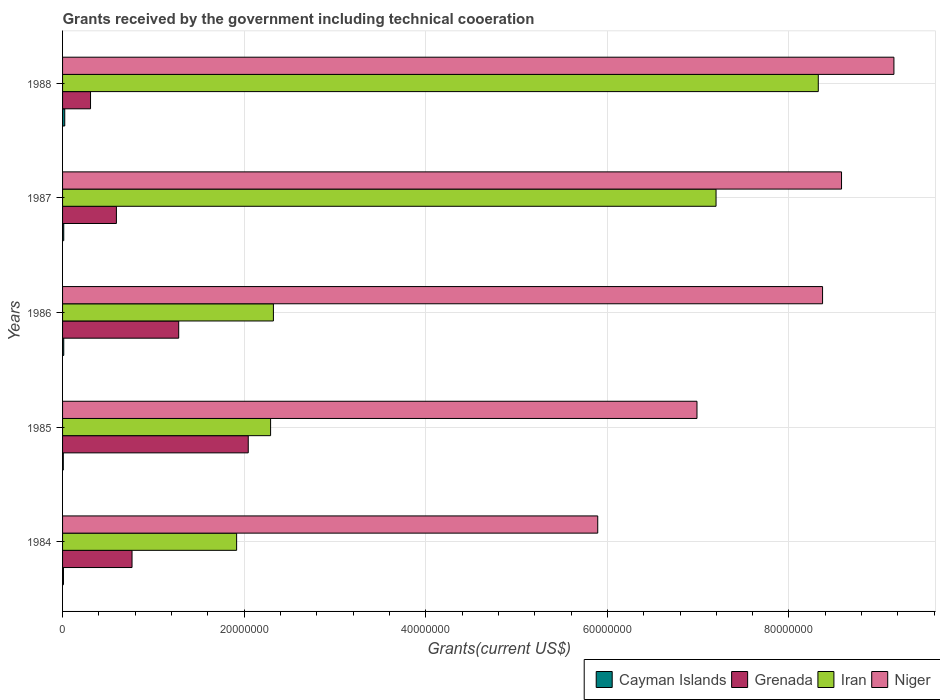How many different coloured bars are there?
Provide a succinct answer. 4. Are the number of bars per tick equal to the number of legend labels?
Your answer should be very brief. Yes. How many bars are there on the 4th tick from the bottom?
Your response must be concise. 4. What is the label of the 1st group of bars from the top?
Provide a short and direct response. 1988. In how many cases, is the number of bars for a given year not equal to the number of legend labels?
Your answer should be very brief. 0. What is the total grants received by the government in Iran in 1986?
Your response must be concise. 2.32e+07. Across all years, what is the minimum total grants received by the government in Grenada?
Keep it short and to the point. 3.08e+06. In which year was the total grants received by the government in Grenada maximum?
Ensure brevity in your answer.  1985. What is the total total grants received by the government in Cayman Islands in the graph?
Keep it short and to the point. 6.80e+05. What is the difference between the total grants received by the government in Iran in 1985 and that in 1986?
Offer a very short reply. -3.10e+05. What is the difference between the total grants received by the government in Iran in 1988 and the total grants received by the government in Cayman Islands in 1985?
Offer a terse response. 8.32e+07. What is the average total grants received by the government in Iran per year?
Your answer should be very brief. 4.41e+07. In the year 1988, what is the difference between the total grants received by the government in Niger and total grants received by the government in Cayman Islands?
Offer a terse response. 9.13e+07. What is the ratio of the total grants received by the government in Niger in 1985 to that in 1987?
Make the answer very short. 0.81. What is the difference between the highest and the second highest total grants received by the government in Grenada?
Ensure brevity in your answer.  7.66e+06. What is the difference between the highest and the lowest total grants received by the government in Iran?
Your response must be concise. 6.41e+07. In how many years, is the total grants received by the government in Cayman Islands greater than the average total grants received by the government in Cayman Islands taken over all years?
Your answer should be compact. 1. What does the 2nd bar from the top in 1988 represents?
Offer a very short reply. Iran. What does the 4th bar from the bottom in 1987 represents?
Give a very brief answer. Niger. Is it the case that in every year, the sum of the total grants received by the government in Niger and total grants received by the government in Cayman Islands is greater than the total grants received by the government in Grenada?
Your answer should be very brief. Yes. How many bars are there?
Ensure brevity in your answer.  20. Are all the bars in the graph horizontal?
Provide a succinct answer. Yes. What is the difference between two consecutive major ticks on the X-axis?
Your answer should be very brief. 2.00e+07. Does the graph contain any zero values?
Provide a succinct answer. No. Where does the legend appear in the graph?
Provide a short and direct response. Bottom right. How many legend labels are there?
Your answer should be very brief. 4. What is the title of the graph?
Keep it short and to the point. Grants received by the government including technical cooeration. Does "Hong Kong" appear as one of the legend labels in the graph?
Offer a terse response. No. What is the label or title of the X-axis?
Your answer should be compact. Grants(current US$). What is the Grants(current US$) in Grenada in 1984?
Your response must be concise. 7.65e+06. What is the Grants(current US$) in Iran in 1984?
Provide a succinct answer. 1.92e+07. What is the Grants(current US$) of Niger in 1984?
Give a very brief answer. 5.89e+07. What is the Grants(current US$) in Grenada in 1985?
Offer a very short reply. 2.04e+07. What is the Grants(current US$) of Iran in 1985?
Your response must be concise. 2.29e+07. What is the Grants(current US$) of Niger in 1985?
Ensure brevity in your answer.  6.99e+07. What is the Grants(current US$) of Grenada in 1986?
Provide a succinct answer. 1.28e+07. What is the Grants(current US$) of Iran in 1986?
Give a very brief answer. 2.32e+07. What is the Grants(current US$) of Niger in 1986?
Your response must be concise. 8.37e+07. What is the Grants(current US$) in Cayman Islands in 1987?
Make the answer very short. 1.30e+05. What is the Grants(current US$) in Grenada in 1987?
Your answer should be compact. 5.93e+06. What is the Grants(current US$) in Iran in 1987?
Provide a succinct answer. 7.20e+07. What is the Grants(current US$) in Niger in 1987?
Your answer should be compact. 8.58e+07. What is the Grants(current US$) in Grenada in 1988?
Your response must be concise. 3.08e+06. What is the Grants(current US$) of Iran in 1988?
Provide a succinct answer. 8.32e+07. What is the Grants(current US$) of Niger in 1988?
Give a very brief answer. 9.16e+07. Across all years, what is the maximum Grants(current US$) in Grenada?
Provide a short and direct response. 2.04e+07. Across all years, what is the maximum Grants(current US$) of Iran?
Your answer should be very brief. 8.32e+07. Across all years, what is the maximum Grants(current US$) in Niger?
Make the answer very short. 9.16e+07. Across all years, what is the minimum Grants(current US$) of Grenada?
Your response must be concise. 3.08e+06. Across all years, what is the minimum Grants(current US$) in Iran?
Offer a terse response. 1.92e+07. Across all years, what is the minimum Grants(current US$) in Niger?
Offer a very short reply. 5.89e+07. What is the total Grants(current US$) in Cayman Islands in the graph?
Give a very brief answer. 6.80e+05. What is the total Grants(current US$) in Grenada in the graph?
Make the answer very short. 4.99e+07. What is the total Grants(current US$) of Iran in the graph?
Keep it short and to the point. 2.20e+08. What is the total Grants(current US$) of Niger in the graph?
Make the answer very short. 3.90e+08. What is the difference between the Grants(current US$) of Grenada in 1984 and that in 1985?
Provide a succinct answer. -1.28e+07. What is the difference between the Grants(current US$) in Iran in 1984 and that in 1985?
Make the answer very short. -3.74e+06. What is the difference between the Grants(current US$) in Niger in 1984 and that in 1985?
Your response must be concise. -1.09e+07. What is the difference between the Grants(current US$) of Cayman Islands in 1984 and that in 1986?
Your answer should be very brief. -3.00e+04. What is the difference between the Grants(current US$) of Grenada in 1984 and that in 1986?
Your response must be concise. -5.14e+06. What is the difference between the Grants(current US$) in Iran in 1984 and that in 1986?
Your response must be concise. -4.05e+06. What is the difference between the Grants(current US$) of Niger in 1984 and that in 1986?
Ensure brevity in your answer.  -2.48e+07. What is the difference between the Grants(current US$) in Grenada in 1984 and that in 1987?
Ensure brevity in your answer.  1.72e+06. What is the difference between the Grants(current US$) in Iran in 1984 and that in 1987?
Your answer should be very brief. -5.28e+07. What is the difference between the Grants(current US$) in Niger in 1984 and that in 1987?
Offer a very short reply. -2.68e+07. What is the difference between the Grants(current US$) of Grenada in 1984 and that in 1988?
Offer a very short reply. 4.57e+06. What is the difference between the Grants(current US$) of Iran in 1984 and that in 1988?
Offer a very short reply. -6.41e+07. What is the difference between the Grants(current US$) in Niger in 1984 and that in 1988?
Make the answer very short. -3.26e+07. What is the difference between the Grants(current US$) in Grenada in 1985 and that in 1986?
Your answer should be very brief. 7.66e+06. What is the difference between the Grants(current US$) of Iran in 1985 and that in 1986?
Keep it short and to the point. -3.10e+05. What is the difference between the Grants(current US$) of Niger in 1985 and that in 1986?
Keep it short and to the point. -1.38e+07. What is the difference between the Grants(current US$) in Grenada in 1985 and that in 1987?
Your answer should be very brief. 1.45e+07. What is the difference between the Grants(current US$) in Iran in 1985 and that in 1987?
Provide a short and direct response. -4.91e+07. What is the difference between the Grants(current US$) of Niger in 1985 and that in 1987?
Your answer should be compact. -1.59e+07. What is the difference between the Grants(current US$) of Cayman Islands in 1985 and that in 1988?
Ensure brevity in your answer.  -1.60e+05. What is the difference between the Grants(current US$) of Grenada in 1985 and that in 1988?
Offer a terse response. 1.74e+07. What is the difference between the Grants(current US$) of Iran in 1985 and that in 1988?
Give a very brief answer. -6.03e+07. What is the difference between the Grants(current US$) in Niger in 1985 and that in 1988?
Offer a terse response. -2.17e+07. What is the difference between the Grants(current US$) in Cayman Islands in 1986 and that in 1987?
Give a very brief answer. 0. What is the difference between the Grants(current US$) of Grenada in 1986 and that in 1987?
Provide a succinct answer. 6.86e+06. What is the difference between the Grants(current US$) in Iran in 1986 and that in 1987?
Ensure brevity in your answer.  -4.88e+07. What is the difference between the Grants(current US$) of Niger in 1986 and that in 1987?
Provide a short and direct response. -2.09e+06. What is the difference between the Grants(current US$) of Cayman Islands in 1986 and that in 1988?
Give a very brief answer. -1.10e+05. What is the difference between the Grants(current US$) of Grenada in 1986 and that in 1988?
Make the answer very short. 9.71e+06. What is the difference between the Grants(current US$) of Iran in 1986 and that in 1988?
Offer a very short reply. -6.00e+07. What is the difference between the Grants(current US$) in Niger in 1986 and that in 1988?
Provide a succinct answer. -7.86e+06. What is the difference between the Grants(current US$) in Cayman Islands in 1987 and that in 1988?
Give a very brief answer. -1.10e+05. What is the difference between the Grants(current US$) of Grenada in 1987 and that in 1988?
Offer a very short reply. 2.85e+06. What is the difference between the Grants(current US$) of Iran in 1987 and that in 1988?
Your answer should be compact. -1.13e+07. What is the difference between the Grants(current US$) of Niger in 1987 and that in 1988?
Your answer should be very brief. -5.77e+06. What is the difference between the Grants(current US$) in Cayman Islands in 1984 and the Grants(current US$) in Grenada in 1985?
Your answer should be very brief. -2.04e+07. What is the difference between the Grants(current US$) in Cayman Islands in 1984 and the Grants(current US$) in Iran in 1985?
Offer a very short reply. -2.28e+07. What is the difference between the Grants(current US$) of Cayman Islands in 1984 and the Grants(current US$) of Niger in 1985?
Your response must be concise. -6.98e+07. What is the difference between the Grants(current US$) in Grenada in 1984 and the Grants(current US$) in Iran in 1985?
Offer a very short reply. -1.53e+07. What is the difference between the Grants(current US$) of Grenada in 1984 and the Grants(current US$) of Niger in 1985?
Give a very brief answer. -6.22e+07. What is the difference between the Grants(current US$) of Iran in 1984 and the Grants(current US$) of Niger in 1985?
Ensure brevity in your answer.  -5.07e+07. What is the difference between the Grants(current US$) of Cayman Islands in 1984 and the Grants(current US$) of Grenada in 1986?
Your response must be concise. -1.27e+07. What is the difference between the Grants(current US$) in Cayman Islands in 1984 and the Grants(current US$) in Iran in 1986?
Provide a short and direct response. -2.31e+07. What is the difference between the Grants(current US$) of Cayman Islands in 1984 and the Grants(current US$) of Niger in 1986?
Offer a very short reply. -8.36e+07. What is the difference between the Grants(current US$) of Grenada in 1984 and the Grants(current US$) of Iran in 1986?
Offer a terse response. -1.56e+07. What is the difference between the Grants(current US$) in Grenada in 1984 and the Grants(current US$) in Niger in 1986?
Ensure brevity in your answer.  -7.60e+07. What is the difference between the Grants(current US$) in Iran in 1984 and the Grants(current US$) in Niger in 1986?
Your answer should be compact. -6.45e+07. What is the difference between the Grants(current US$) of Cayman Islands in 1984 and the Grants(current US$) of Grenada in 1987?
Give a very brief answer. -5.83e+06. What is the difference between the Grants(current US$) of Cayman Islands in 1984 and the Grants(current US$) of Iran in 1987?
Ensure brevity in your answer.  -7.19e+07. What is the difference between the Grants(current US$) of Cayman Islands in 1984 and the Grants(current US$) of Niger in 1987?
Your answer should be compact. -8.57e+07. What is the difference between the Grants(current US$) of Grenada in 1984 and the Grants(current US$) of Iran in 1987?
Provide a short and direct response. -6.43e+07. What is the difference between the Grants(current US$) of Grenada in 1984 and the Grants(current US$) of Niger in 1987?
Your answer should be very brief. -7.81e+07. What is the difference between the Grants(current US$) of Iran in 1984 and the Grants(current US$) of Niger in 1987?
Provide a short and direct response. -6.66e+07. What is the difference between the Grants(current US$) in Cayman Islands in 1984 and the Grants(current US$) in Grenada in 1988?
Make the answer very short. -2.98e+06. What is the difference between the Grants(current US$) of Cayman Islands in 1984 and the Grants(current US$) of Iran in 1988?
Offer a terse response. -8.31e+07. What is the difference between the Grants(current US$) in Cayman Islands in 1984 and the Grants(current US$) in Niger in 1988?
Offer a very short reply. -9.15e+07. What is the difference between the Grants(current US$) in Grenada in 1984 and the Grants(current US$) in Iran in 1988?
Your answer should be very brief. -7.56e+07. What is the difference between the Grants(current US$) of Grenada in 1984 and the Grants(current US$) of Niger in 1988?
Make the answer very short. -8.39e+07. What is the difference between the Grants(current US$) in Iran in 1984 and the Grants(current US$) in Niger in 1988?
Your answer should be compact. -7.24e+07. What is the difference between the Grants(current US$) in Cayman Islands in 1985 and the Grants(current US$) in Grenada in 1986?
Give a very brief answer. -1.27e+07. What is the difference between the Grants(current US$) in Cayman Islands in 1985 and the Grants(current US$) in Iran in 1986?
Your answer should be very brief. -2.31e+07. What is the difference between the Grants(current US$) of Cayman Islands in 1985 and the Grants(current US$) of Niger in 1986?
Provide a succinct answer. -8.36e+07. What is the difference between the Grants(current US$) in Grenada in 1985 and the Grants(current US$) in Iran in 1986?
Your answer should be compact. -2.77e+06. What is the difference between the Grants(current US$) in Grenada in 1985 and the Grants(current US$) in Niger in 1986?
Give a very brief answer. -6.32e+07. What is the difference between the Grants(current US$) in Iran in 1985 and the Grants(current US$) in Niger in 1986?
Ensure brevity in your answer.  -6.08e+07. What is the difference between the Grants(current US$) in Cayman Islands in 1985 and the Grants(current US$) in Grenada in 1987?
Your response must be concise. -5.85e+06. What is the difference between the Grants(current US$) of Cayman Islands in 1985 and the Grants(current US$) of Iran in 1987?
Give a very brief answer. -7.19e+07. What is the difference between the Grants(current US$) of Cayman Islands in 1985 and the Grants(current US$) of Niger in 1987?
Provide a short and direct response. -8.57e+07. What is the difference between the Grants(current US$) of Grenada in 1985 and the Grants(current US$) of Iran in 1987?
Your response must be concise. -5.15e+07. What is the difference between the Grants(current US$) of Grenada in 1985 and the Grants(current US$) of Niger in 1987?
Your answer should be compact. -6.53e+07. What is the difference between the Grants(current US$) in Iran in 1985 and the Grants(current US$) in Niger in 1987?
Provide a succinct answer. -6.29e+07. What is the difference between the Grants(current US$) in Cayman Islands in 1985 and the Grants(current US$) in Iran in 1988?
Keep it short and to the point. -8.32e+07. What is the difference between the Grants(current US$) in Cayman Islands in 1985 and the Grants(current US$) in Niger in 1988?
Keep it short and to the point. -9.15e+07. What is the difference between the Grants(current US$) in Grenada in 1985 and the Grants(current US$) in Iran in 1988?
Provide a succinct answer. -6.28e+07. What is the difference between the Grants(current US$) in Grenada in 1985 and the Grants(current US$) in Niger in 1988?
Your response must be concise. -7.11e+07. What is the difference between the Grants(current US$) of Iran in 1985 and the Grants(current US$) of Niger in 1988?
Your response must be concise. -6.86e+07. What is the difference between the Grants(current US$) of Cayman Islands in 1986 and the Grants(current US$) of Grenada in 1987?
Keep it short and to the point. -5.80e+06. What is the difference between the Grants(current US$) of Cayman Islands in 1986 and the Grants(current US$) of Iran in 1987?
Keep it short and to the point. -7.18e+07. What is the difference between the Grants(current US$) in Cayman Islands in 1986 and the Grants(current US$) in Niger in 1987?
Offer a terse response. -8.57e+07. What is the difference between the Grants(current US$) of Grenada in 1986 and the Grants(current US$) of Iran in 1987?
Offer a terse response. -5.92e+07. What is the difference between the Grants(current US$) of Grenada in 1986 and the Grants(current US$) of Niger in 1987?
Keep it short and to the point. -7.30e+07. What is the difference between the Grants(current US$) in Iran in 1986 and the Grants(current US$) in Niger in 1987?
Provide a short and direct response. -6.26e+07. What is the difference between the Grants(current US$) in Cayman Islands in 1986 and the Grants(current US$) in Grenada in 1988?
Offer a terse response. -2.95e+06. What is the difference between the Grants(current US$) of Cayman Islands in 1986 and the Grants(current US$) of Iran in 1988?
Keep it short and to the point. -8.31e+07. What is the difference between the Grants(current US$) in Cayman Islands in 1986 and the Grants(current US$) in Niger in 1988?
Your response must be concise. -9.14e+07. What is the difference between the Grants(current US$) of Grenada in 1986 and the Grants(current US$) of Iran in 1988?
Your answer should be very brief. -7.04e+07. What is the difference between the Grants(current US$) in Grenada in 1986 and the Grants(current US$) in Niger in 1988?
Your answer should be very brief. -7.88e+07. What is the difference between the Grants(current US$) in Iran in 1986 and the Grants(current US$) in Niger in 1988?
Provide a short and direct response. -6.83e+07. What is the difference between the Grants(current US$) of Cayman Islands in 1987 and the Grants(current US$) of Grenada in 1988?
Provide a succinct answer. -2.95e+06. What is the difference between the Grants(current US$) of Cayman Islands in 1987 and the Grants(current US$) of Iran in 1988?
Offer a very short reply. -8.31e+07. What is the difference between the Grants(current US$) of Cayman Islands in 1987 and the Grants(current US$) of Niger in 1988?
Offer a very short reply. -9.14e+07. What is the difference between the Grants(current US$) in Grenada in 1987 and the Grants(current US$) in Iran in 1988?
Your answer should be very brief. -7.73e+07. What is the difference between the Grants(current US$) in Grenada in 1987 and the Grants(current US$) in Niger in 1988?
Keep it short and to the point. -8.56e+07. What is the difference between the Grants(current US$) in Iran in 1987 and the Grants(current US$) in Niger in 1988?
Your answer should be very brief. -1.96e+07. What is the average Grants(current US$) of Cayman Islands per year?
Provide a succinct answer. 1.36e+05. What is the average Grants(current US$) in Grenada per year?
Ensure brevity in your answer.  9.98e+06. What is the average Grants(current US$) in Iran per year?
Offer a terse response. 4.41e+07. What is the average Grants(current US$) in Niger per year?
Offer a very short reply. 7.80e+07. In the year 1984, what is the difference between the Grants(current US$) of Cayman Islands and Grants(current US$) of Grenada?
Keep it short and to the point. -7.55e+06. In the year 1984, what is the difference between the Grants(current US$) of Cayman Islands and Grants(current US$) of Iran?
Provide a short and direct response. -1.91e+07. In the year 1984, what is the difference between the Grants(current US$) in Cayman Islands and Grants(current US$) in Niger?
Ensure brevity in your answer.  -5.88e+07. In the year 1984, what is the difference between the Grants(current US$) of Grenada and Grants(current US$) of Iran?
Offer a very short reply. -1.15e+07. In the year 1984, what is the difference between the Grants(current US$) of Grenada and Grants(current US$) of Niger?
Make the answer very short. -5.13e+07. In the year 1984, what is the difference between the Grants(current US$) of Iran and Grants(current US$) of Niger?
Provide a succinct answer. -3.98e+07. In the year 1985, what is the difference between the Grants(current US$) of Cayman Islands and Grants(current US$) of Grenada?
Keep it short and to the point. -2.04e+07. In the year 1985, what is the difference between the Grants(current US$) of Cayman Islands and Grants(current US$) of Iran?
Provide a succinct answer. -2.28e+07. In the year 1985, what is the difference between the Grants(current US$) in Cayman Islands and Grants(current US$) in Niger?
Your answer should be very brief. -6.98e+07. In the year 1985, what is the difference between the Grants(current US$) of Grenada and Grants(current US$) of Iran?
Offer a very short reply. -2.46e+06. In the year 1985, what is the difference between the Grants(current US$) of Grenada and Grants(current US$) of Niger?
Provide a short and direct response. -4.94e+07. In the year 1985, what is the difference between the Grants(current US$) of Iran and Grants(current US$) of Niger?
Ensure brevity in your answer.  -4.70e+07. In the year 1986, what is the difference between the Grants(current US$) in Cayman Islands and Grants(current US$) in Grenada?
Your response must be concise. -1.27e+07. In the year 1986, what is the difference between the Grants(current US$) in Cayman Islands and Grants(current US$) in Iran?
Offer a terse response. -2.31e+07. In the year 1986, what is the difference between the Grants(current US$) of Cayman Islands and Grants(current US$) of Niger?
Ensure brevity in your answer.  -8.36e+07. In the year 1986, what is the difference between the Grants(current US$) of Grenada and Grants(current US$) of Iran?
Ensure brevity in your answer.  -1.04e+07. In the year 1986, what is the difference between the Grants(current US$) in Grenada and Grants(current US$) in Niger?
Give a very brief answer. -7.09e+07. In the year 1986, what is the difference between the Grants(current US$) in Iran and Grants(current US$) in Niger?
Make the answer very short. -6.05e+07. In the year 1987, what is the difference between the Grants(current US$) of Cayman Islands and Grants(current US$) of Grenada?
Make the answer very short. -5.80e+06. In the year 1987, what is the difference between the Grants(current US$) in Cayman Islands and Grants(current US$) in Iran?
Keep it short and to the point. -7.18e+07. In the year 1987, what is the difference between the Grants(current US$) of Cayman Islands and Grants(current US$) of Niger?
Offer a very short reply. -8.57e+07. In the year 1987, what is the difference between the Grants(current US$) in Grenada and Grants(current US$) in Iran?
Make the answer very short. -6.60e+07. In the year 1987, what is the difference between the Grants(current US$) in Grenada and Grants(current US$) in Niger?
Your answer should be very brief. -7.99e+07. In the year 1987, what is the difference between the Grants(current US$) of Iran and Grants(current US$) of Niger?
Make the answer very short. -1.38e+07. In the year 1988, what is the difference between the Grants(current US$) in Cayman Islands and Grants(current US$) in Grenada?
Your answer should be compact. -2.84e+06. In the year 1988, what is the difference between the Grants(current US$) of Cayman Islands and Grants(current US$) of Iran?
Make the answer very short. -8.30e+07. In the year 1988, what is the difference between the Grants(current US$) in Cayman Islands and Grants(current US$) in Niger?
Make the answer very short. -9.13e+07. In the year 1988, what is the difference between the Grants(current US$) of Grenada and Grants(current US$) of Iran?
Provide a short and direct response. -8.02e+07. In the year 1988, what is the difference between the Grants(current US$) of Grenada and Grants(current US$) of Niger?
Offer a terse response. -8.85e+07. In the year 1988, what is the difference between the Grants(current US$) of Iran and Grants(current US$) of Niger?
Provide a succinct answer. -8.33e+06. What is the ratio of the Grants(current US$) in Grenada in 1984 to that in 1985?
Your response must be concise. 0.37. What is the ratio of the Grants(current US$) of Iran in 1984 to that in 1985?
Offer a very short reply. 0.84. What is the ratio of the Grants(current US$) of Niger in 1984 to that in 1985?
Your response must be concise. 0.84. What is the ratio of the Grants(current US$) of Cayman Islands in 1984 to that in 1986?
Make the answer very short. 0.77. What is the ratio of the Grants(current US$) of Grenada in 1984 to that in 1986?
Provide a short and direct response. 0.6. What is the ratio of the Grants(current US$) of Iran in 1984 to that in 1986?
Offer a terse response. 0.83. What is the ratio of the Grants(current US$) of Niger in 1984 to that in 1986?
Offer a terse response. 0.7. What is the ratio of the Grants(current US$) in Cayman Islands in 1984 to that in 1987?
Make the answer very short. 0.77. What is the ratio of the Grants(current US$) in Grenada in 1984 to that in 1987?
Provide a succinct answer. 1.29. What is the ratio of the Grants(current US$) of Iran in 1984 to that in 1987?
Offer a terse response. 0.27. What is the ratio of the Grants(current US$) of Niger in 1984 to that in 1987?
Offer a terse response. 0.69. What is the ratio of the Grants(current US$) in Cayman Islands in 1984 to that in 1988?
Provide a short and direct response. 0.42. What is the ratio of the Grants(current US$) in Grenada in 1984 to that in 1988?
Offer a very short reply. 2.48. What is the ratio of the Grants(current US$) in Iran in 1984 to that in 1988?
Ensure brevity in your answer.  0.23. What is the ratio of the Grants(current US$) of Niger in 1984 to that in 1988?
Keep it short and to the point. 0.64. What is the ratio of the Grants(current US$) in Cayman Islands in 1985 to that in 1986?
Give a very brief answer. 0.62. What is the ratio of the Grants(current US$) of Grenada in 1985 to that in 1986?
Your answer should be compact. 1.6. What is the ratio of the Grants(current US$) of Iran in 1985 to that in 1986?
Provide a short and direct response. 0.99. What is the ratio of the Grants(current US$) of Niger in 1985 to that in 1986?
Your answer should be very brief. 0.83. What is the ratio of the Grants(current US$) of Cayman Islands in 1985 to that in 1987?
Give a very brief answer. 0.62. What is the ratio of the Grants(current US$) of Grenada in 1985 to that in 1987?
Offer a terse response. 3.45. What is the ratio of the Grants(current US$) of Iran in 1985 to that in 1987?
Offer a terse response. 0.32. What is the ratio of the Grants(current US$) of Niger in 1985 to that in 1987?
Your answer should be compact. 0.81. What is the ratio of the Grants(current US$) of Grenada in 1985 to that in 1988?
Ensure brevity in your answer.  6.64. What is the ratio of the Grants(current US$) of Iran in 1985 to that in 1988?
Your answer should be compact. 0.28. What is the ratio of the Grants(current US$) in Niger in 1985 to that in 1988?
Provide a succinct answer. 0.76. What is the ratio of the Grants(current US$) of Grenada in 1986 to that in 1987?
Make the answer very short. 2.16. What is the ratio of the Grants(current US$) of Iran in 1986 to that in 1987?
Provide a short and direct response. 0.32. What is the ratio of the Grants(current US$) of Niger in 1986 to that in 1987?
Your answer should be very brief. 0.98. What is the ratio of the Grants(current US$) of Cayman Islands in 1986 to that in 1988?
Your answer should be compact. 0.54. What is the ratio of the Grants(current US$) in Grenada in 1986 to that in 1988?
Your response must be concise. 4.15. What is the ratio of the Grants(current US$) of Iran in 1986 to that in 1988?
Give a very brief answer. 0.28. What is the ratio of the Grants(current US$) in Niger in 1986 to that in 1988?
Keep it short and to the point. 0.91. What is the ratio of the Grants(current US$) of Cayman Islands in 1987 to that in 1988?
Offer a very short reply. 0.54. What is the ratio of the Grants(current US$) of Grenada in 1987 to that in 1988?
Your response must be concise. 1.93. What is the ratio of the Grants(current US$) of Iran in 1987 to that in 1988?
Make the answer very short. 0.86. What is the ratio of the Grants(current US$) in Niger in 1987 to that in 1988?
Offer a very short reply. 0.94. What is the difference between the highest and the second highest Grants(current US$) in Cayman Islands?
Provide a short and direct response. 1.10e+05. What is the difference between the highest and the second highest Grants(current US$) in Grenada?
Offer a terse response. 7.66e+06. What is the difference between the highest and the second highest Grants(current US$) in Iran?
Make the answer very short. 1.13e+07. What is the difference between the highest and the second highest Grants(current US$) in Niger?
Make the answer very short. 5.77e+06. What is the difference between the highest and the lowest Grants(current US$) of Cayman Islands?
Your answer should be compact. 1.60e+05. What is the difference between the highest and the lowest Grants(current US$) of Grenada?
Make the answer very short. 1.74e+07. What is the difference between the highest and the lowest Grants(current US$) of Iran?
Ensure brevity in your answer.  6.41e+07. What is the difference between the highest and the lowest Grants(current US$) of Niger?
Offer a very short reply. 3.26e+07. 